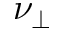<formula> <loc_0><loc_0><loc_500><loc_500>\nu _ { \perp }</formula> 